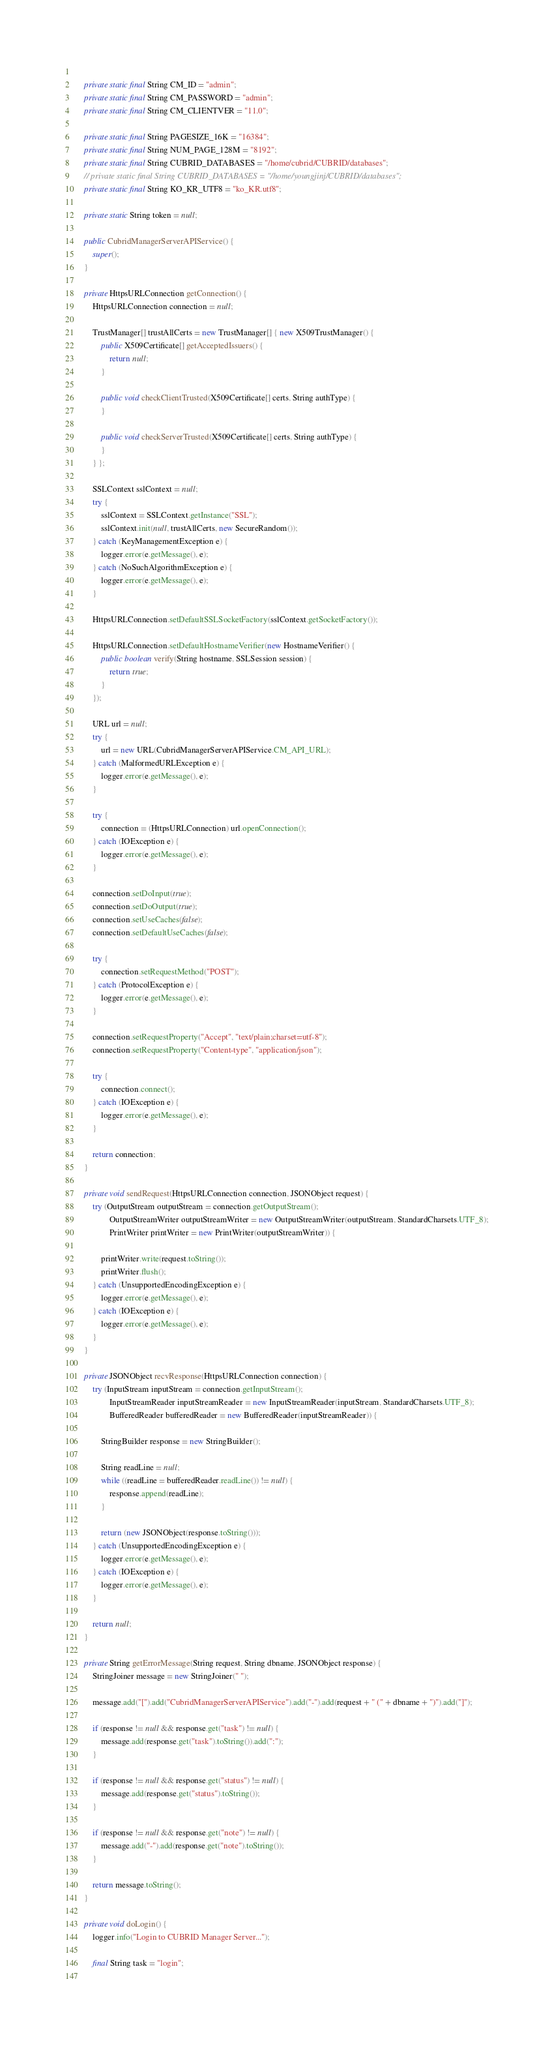<code> <loc_0><loc_0><loc_500><loc_500><_Java_>	
	private static final String CM_ID = "admin";
	private static final String CM_PASSWORD = "admin";
	private static final String CM_CLIENTVER = "11.0";
	
	private static final String PAGESIZE_16K = "16384";
	private static final String NUM_PAGE_128M = "8192";
	private static final String CUBRID_DATABASES = "/home/cubrid/CUBRID/databases";
	// private static final String CUBRID_DATABASES = "/home/youngjinj/CUBRID/databases";
	private static final String KO_KR_UTF8 = "ko_KR.utf8";
	
	private static String token = null;
	
	public CubridManagerServerAPIService() {
		super();
	}
	
	private HttpsURLConnection getConnection() {
		HttpsURLConnection connection = null;

		TrustManager[] trustAllCerts = new TrustManager[] { new X509TrustManager() {
			public X509Certificate[] getAcceptedIssuers() {
				return null;
			}

			public void checkClientTrusted(X509Certificate[] certs, String authType) {
			}

			public void checkServerTrusted(X509Certificate[] certs, String authType) {
			}
		} };

		SSLContext sslContext = null;
		try {
			sslContext = SSLContext.getInstance("SSL");
			sslContext.init(null, trustAllCerts, new SecureRandom());
		} catch (KeyManagementException e) {
			logger.error(e.getMessage(), e);
		} catch (NoSuchAlgorithmException e) {
			logger.error(e.getMessage(), e);
		}

		HttpsURLConnection.setDefaultSSLSocketFactory(sslContext.getSocketFactory());

		HttpsURLConnection.setDefaultHostnameVerifier(new HostnameVerifier() {
			public boolean verify(String hostname, SSLSession session) {
				return true;
			}
		});

		URL url = null;
		try {
			url = new URL(CubridManagerServerAPIService.CM_API_URL);
		} catch (MalformedURLException e) {
			logger.error(e.getMessage(), e);
		}

		try {
			connection = (HttpsURLConnection) url.openConnection();
		} catch (IOException e) {
			logger.error(e.getMessage(), e);
		}

		connection.setDoInput(true);
		connection.setDoOutput(true);
		connection.setUseCaches(false); 
		connection.setDefaultUseCaches(false);
		
		try {
			connection.setRequestMethod("POST");
		} catch (ProtocolException e) {
			logger.error(e.getMessage(), e);
		}

		connection.setRequestProperty("Accept", "text/plain;charset=utf-8");
		connection.setRequestProperty("Content-type", "application/json");

		try {
			connection.connect();
		} catch (IOException e) {
			logger.error(e.getMessage(), e);
		}

		return connection;
	}
	
	private void sendRequest(HttpsURLConnection connection, JSONObject request) {
		try (OutputStream outputStream = connection.getOutputStream();
				OutputStreamWriter outputStreamWriter = new OutputStreamWriter(outputStream, StandardCharsets.UTF_8);
				PrintWriter printWriter = new PrintWriter(outputStreamWriter)) {

			printWriter.write(request.toString());
			printWriter.flush();
		} catch (UnsupportedEncodingException e) {
			logger.error(e.getMessage(), e);
		} catch (IOException e) {
			logger.error(e.getMessage(), e);
		}
	}

	private JSONObject recvResponse(HttpsURLConnection connection) {
		try (InputStream inputStream = connection.getInputStream();
				InputStreamReader inputStreamReader = new InputStreamReader(inputStream, StandardCharsets.UTF_8);
				BufferedReader bufferedReader = new BufferedReader(inputStreamReader)) {

			StringBuilder response = new StringBuilder();
			
			String readLine = null;
			while ((readLine = bufferedReader.readLine()) != null) {
				response.append(readLine);
			}
			
			return (new JSONObject(response.toString()));
		} catch (UnsupportedEncodingException e) {
			logger.error(e.getMessage(), e);
		} catch (IOException e) {
			logger.error(e.getMessage(), e);
		}

		return null;
	}
	
	private String getErrorMessage(String request, String dbname, JSONObject response) {
		StringJoiner message = new StringJoiner(" ");

		message.add("[").add("CubridManagerServerAPIService").add("-").add(request + " (" + dbname + ")").add("]");

		if (response != null && response.get("task") != null) {
			message.add(response.get("task").toString()).add(":");
		}

		if (response != null && response.get("status") != null) {
			message.add(response.get("status").toString());
		}

		if (response != null && response.get("note") != null) {
			message.add("-").add(response.get("note").toString());
		}

		return message.toString();
	}
	
	private void doLogin() {
		logger.info("Login to CUBRID Manager Server...");
		
		final String task = "login";
		</code> 